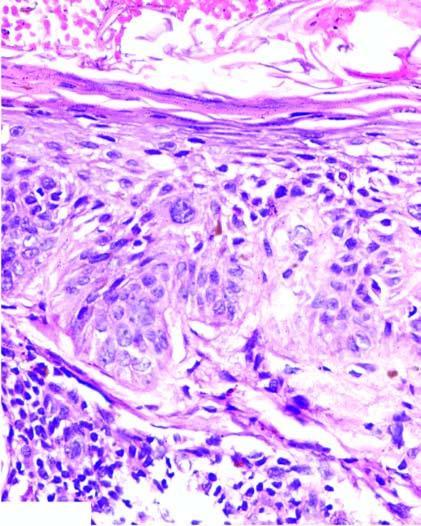re there bizarre atypical squamous cells but the border between the epidermis and dermis is intact ie?
Answer the question using a single word or phrase. Yes 